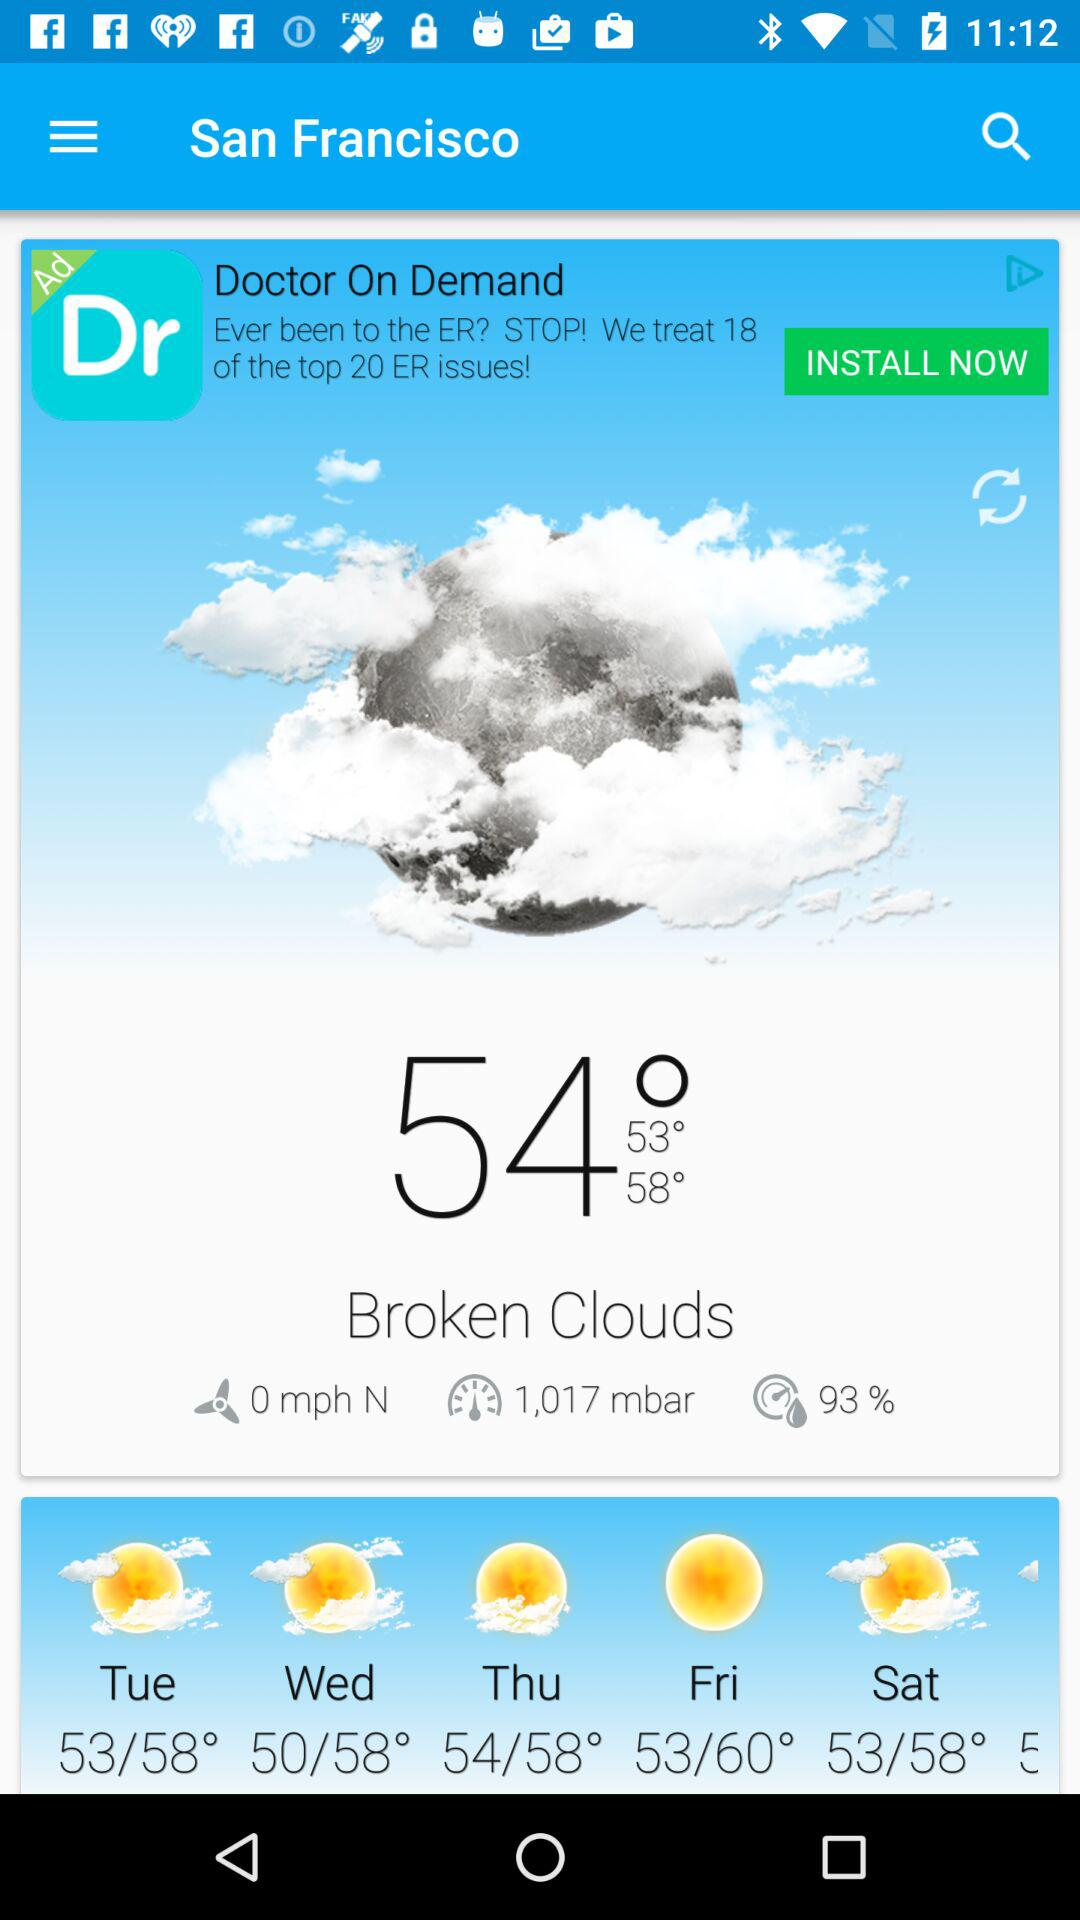How many days of the week are included in the weather forecast?
Answer the question using a single word or phrase. 5 